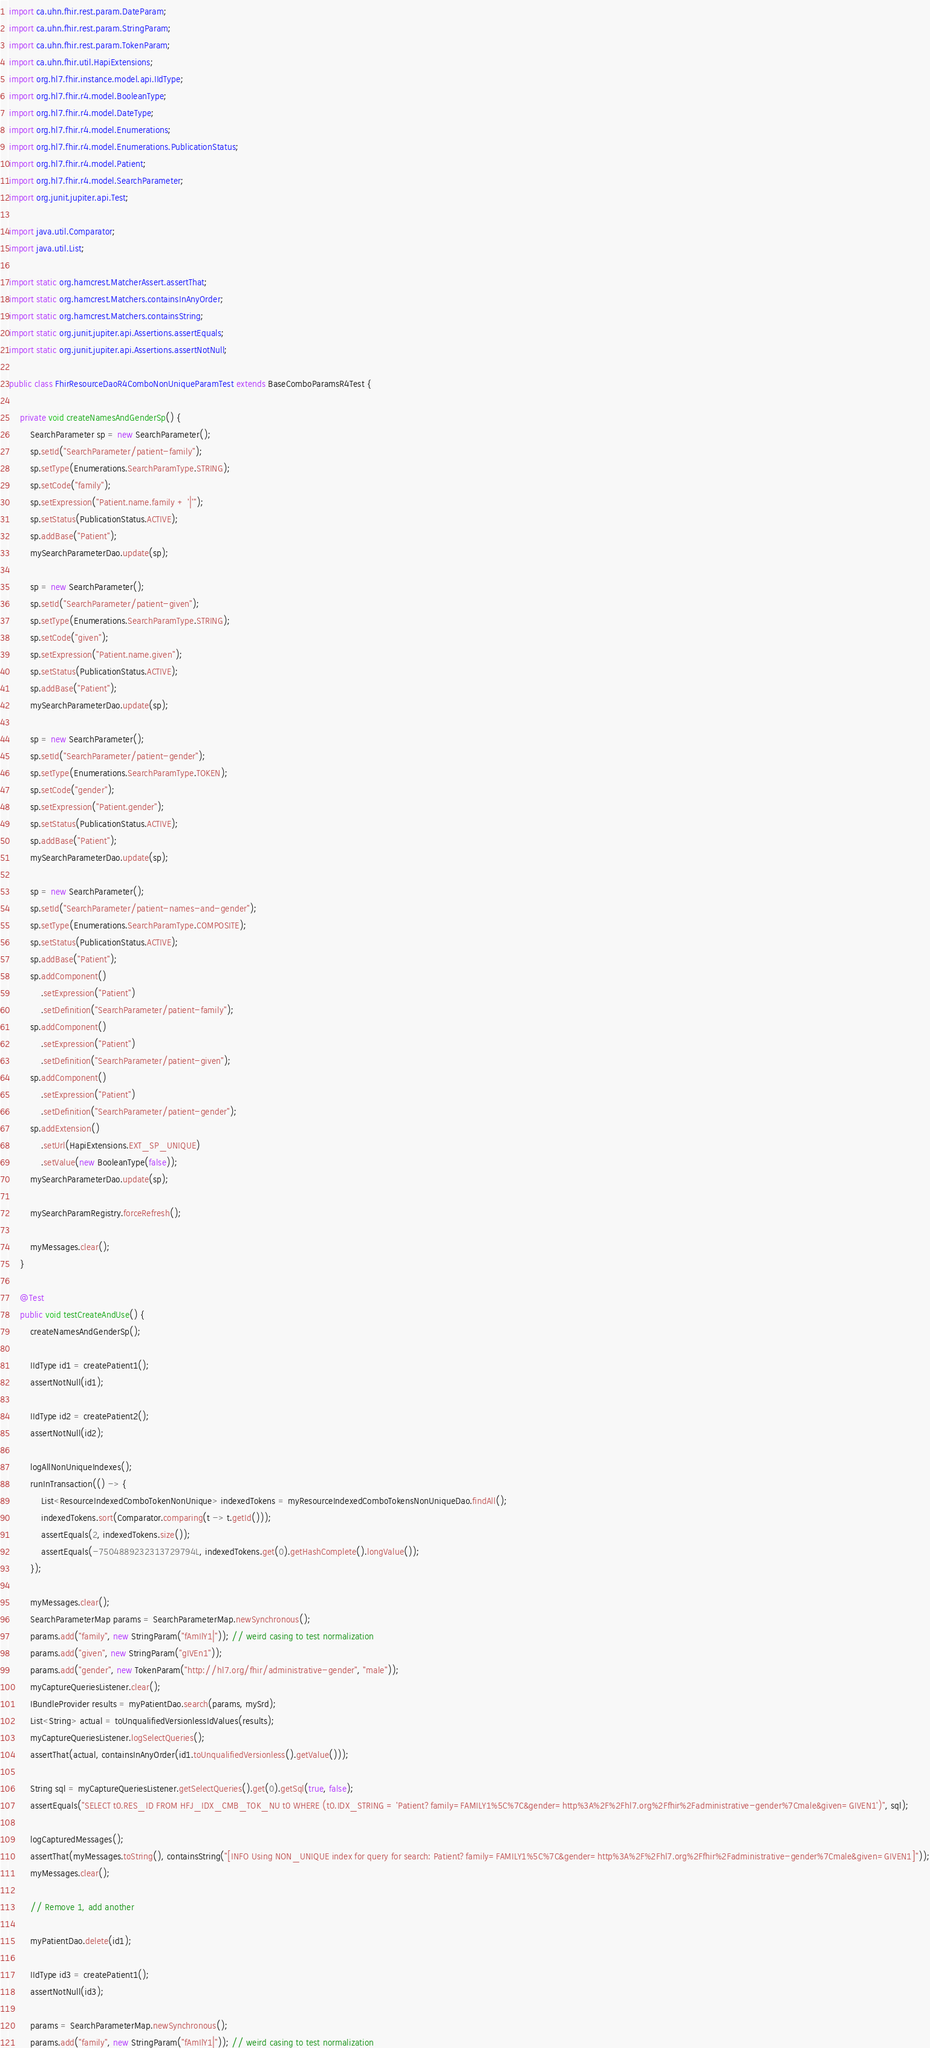Convert code to text. <code><loc_0><loc_0><loc_500><loc_500><_Java_>import ca.uhn.fhir.rest.param.DateParam;
import ca.uhn.fhir.rest.param.StringParam;
import ca.uhn.fhir.rest.param.TokenParam;
import ca.uhn.fhir.util.HapiExtensions;
import org.hl7.fhir.instance.model.api.IIdType;
import org.hl7.fhir.r4.model.BooleanType;
import org.hl7.fhir.r4.model.DateType;
import org.hl7.fhir.r4.model.Enumerations;
import org.hl7.fhir.r4.model.Enumerations.PublicationStatus;
import org.hl7.fhir.r4.model.Patient;
import org.hl7.fhir.r4.model.SearchParameter;
import org.junit.jupiter.api.Test;

import java.util.Comparator;
import java.util.List;

import static org.hamcrest.MatcherAssert.assertThat;
import static org.hamcrest.Matchers.containsInAnyOrder;
import static org.hamcrest.Matchers.containsString;
import static org.junit.jupiter.api.Assertions.assertEquals;
import static org.junit.jupiter.api.Assertions.assertNotNull;

public class FhirResourceDaoR4ComboNonUniqueParamTest extends BaseComboParamsR4Test {

	private void createNamesAndGenderSp() {
		SearchParameter sp = new SearchParameter();
		sp.setId("SearchParameter/patient-family");
		sp.setType(Enumerations.SearchParamType.STRING);
		sp.setCode("family");
		sp.setExpression("Patient.name.family + '|'");
		sp.setStatus(PublicationStatus.ACTIVE);
		sp.addBase("Patient");
		mySearchParameterDao.update(sp);

		sp = new SearchParameter();
		sp.setId("SearchParameter/patient-given");
		sp.setType(Enumerations.SearchParamType.STRING);
		sp.setCode("given");
		sp.setExpression("Patient.name.given");
		sp.setStatus(PublicationStatus.ACTIVE);
		sp.addBase("Patient");
		mySearchParameterDao.update(sp);

		sp = new SearchParameter();
		sp.setId("SearchParameter/patient-gender");
		sp.setType(Enumerations.SearchParamType.TOKEN);
		sp.setCode("gender");
		sp.setExpression("Patient.gender");
		sp.setStatus(PublicationStatus.ACTIVE);
		sp.addBase("Patient");
		mySearchParameterDao.update(sp);

		sp = new SearchParameter();
		sp.setId("SearchParameter/patient-names-and-gender");
		sp.setType(Enumerations.SearchParamType.COMPOSITE);
		sp.setStatus(PublicationStatus.ACTIVE);
		sp.addBase("Patient");
		sp.addComponent()
			.setExpression("Patient")
			.setDefinition("SearchParameter/patient-family");
		sp.addComponent()
			.setExpression("Patient")
			.setDefinition("SearchParameter/patient-given");
		sp.addComponent()
			.setExpression("Patient")
			.setDefinition("SearchParameter/patient-gender");
		sp.addExtension()
			.setUrl(HapiExtensions.EXT_SP_UNIQUE)
			.setValue(new BooleanType(false));
		mySearchParameterDao.update(sp);

		mySearchParamRegistry.forceRefresh();

		myMessages.clear();
	}

	@Test
	public void testCreateAndUse() {
		createNamesAndGenderSp();

		IIdType id1 = createPatient1();
		assertNotNull(id1);

		IIdType id2 = createPatient2();
		assertNotNull(id2);

		logAllNonUniqueIndexes();
		runInTransaction(() -> {
			List<ResourceIndexedComboTokenNonUnique> indexedTokens = myResourceIndexedComboTokensNonUniqueDao.findAll();
			indexedTokens.sort(Comparator.comparing(t -> t.getId()));
			assertEquals(2, indexedTokens.size());
			assertEquals(-7504889232313729794L, indexedTokens.get(0).getHashComplete().longValue());
		});

		myMessages.clear();
		SearchParameterMap params = SearchParameterMap.newSynchronous();
		params.add("family", new StringParam("fAmIlY1|")); // weird casing to test normalization
		params.add("given", new StringParam("gIVEn1"));
		params.add("gender", new TokenParam("http://hl7.org/fhir/administrative-gender", "male"));
		myCaptureQueriesListener.clear();
		IBundleProvider results = myPatientDao.search(params, mySrd);
		List<String> actual = toUnqualifiedVersionlessIdValues(results);
		myCaptureQueriesListener.logSelectQueries();
		assertThat(actual, containsInAnyOrder(id1.toUnqualifiedVersionless().getValue()));

		String sql = myCaptureQueriesListener.getSelectQueries().get(0).getSql(true, false);
		assertEquals("SELECT t0.RES_ID FROM HFJ_IDX_CMB_TOK_NU t0 WHERE (t0.IDX_STRING = 'Patient?family=FAMILY1%5C%7C&gender=http%3A%2F%2Fhl7.org%2Ffhir%2Fadministrative-gender%7Cmale&given=GIVEN1')", sql);

		logCapturedMessages();
		assertThat(myMessages.toString(), containsString("[INFO Using NON_UNIQUE index for query for search: Patient?family=FAMILY1%5C%7C&gender=http%3A%2F%2Fhl7.org%2Ffhir%2Fadministrative-gender%7Cmale&given=GIVEN1]"));
		myMessages.clear();

		// Remove 1, add another

		myPatientDao.delete(id1);

		IIdType id3 = createPatient1();
		assertNotNull(id3);

		params = SearchParameterMap.newSynchronous();
		params.add("family", new StringParam("fAmIlY1|")); // weird casing to test normalization</code> 